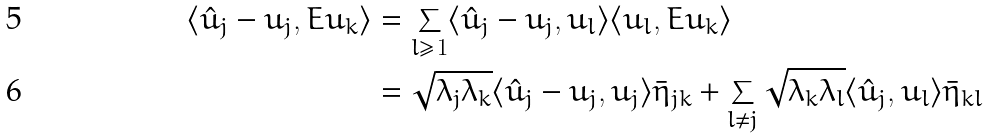Convert formula to latex. <formula><loc_0><loc_0><loc_500><loc_500>\langle \hat { u } _ { j } - u _ { j } , E u _ { k } \rangle & = \sum _ { l \geq 1 } \langle \hat { u } _ { j } - u _ { j } , u _ { l } \rangle \langle u _ { l } , E u _ { k } \rangle \\ & = \sqrt { \lambda _ { j } \lambda _ { k } } \langle \hat { u } _ { j } - u _ { j } , u _ { j } \rangle \bar { \eta } _ { j k } + \sum _ { l \neq j } \sqrt { \lambda _ { k } \lambda _ { l } } \langle \hat { u } _ { j } , u _ { l } \rangle \bar { \eta } _ { k l }</formula> 